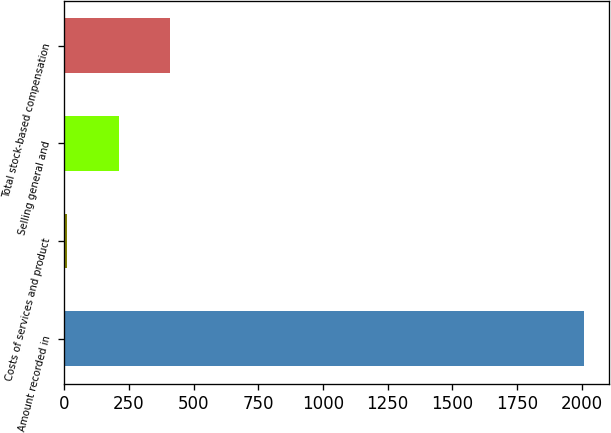<chart> <loc_0><loc_0><loc_500><loc_500><bar_chart><fcel>Amount recorded in<fcel>Costs of services and product<fcel>Selling general and<fcel>Total stock-based compensation<nl><fcel>2007<fcel>10.8<fcel>210.42<fcel>410.04<nl></chart> 